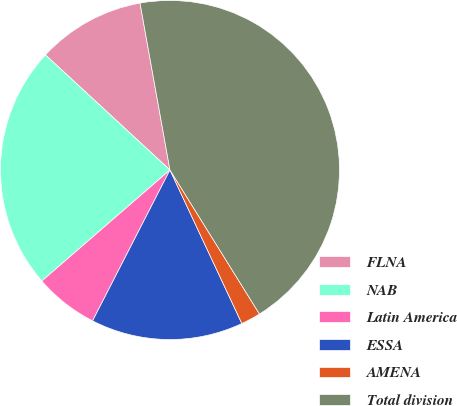Convert chart. <chart><loc_0><loc_0><loc_500><loc_500><pie_chart><fcel>FLNA<fcel>NAB<fcel>Latin America<fcel>ESSA<fcel>AMENA<fcel>Total division<nl><fcel>10.3%<fcel>23.24%<fcel>6.09%<fcel>14.51%<fcel>1.88%<fcel>43.97%<nl></chart> 